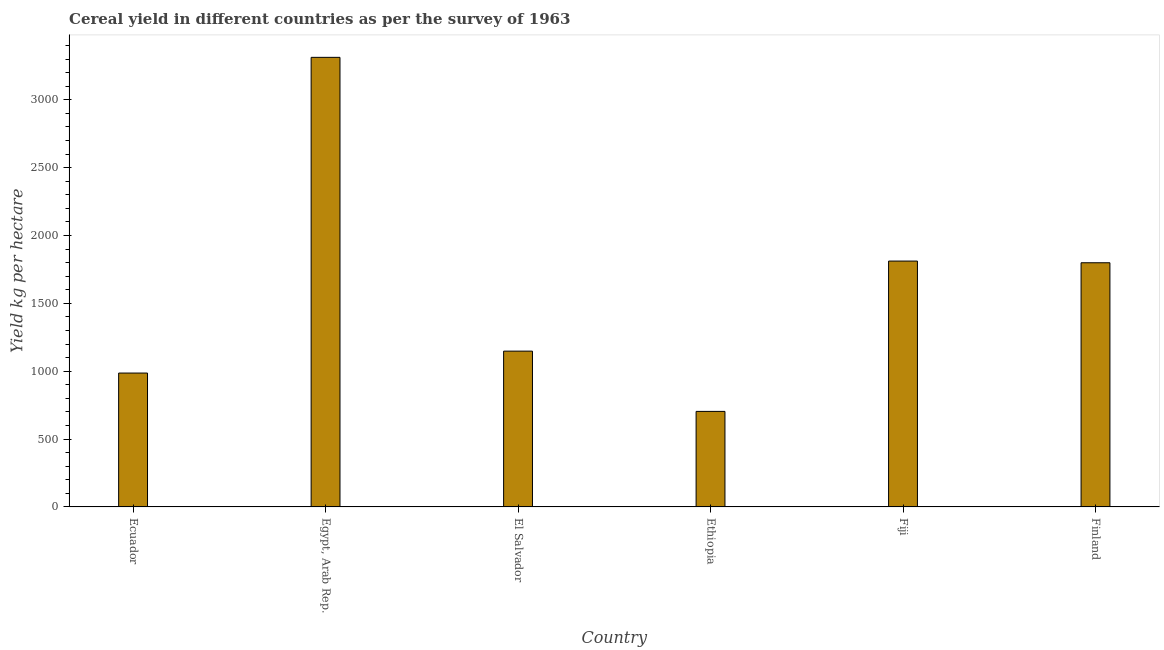Does the graph contain any zero values?
Offer a very short reply. No. Does the graph contain grids?
Your response must be concise. No. What is the title of the graph?
Your answer should be very brief. Cereal yield in different countries as per the survey of 1963. What is the label or title of the X-axis?
Provide a succinct answer. Country. What is the label or title of the Y-axis?
Keep it short and to the point. Yield kg per hectare. What is the cereal yield in El Salvador?
Your answer should be very brief. 1148.03. Across all countries, what is the maximum cereal yield?
Provide a short and direct response. 3312.81. Across all countries, what is the minimum cereal yield?
Your answer should be very brief. 703.99. In which country was the cereal yield maximum?
Your response must be concise. Egypt, Arab Rep. In which country was the cereal yield minimum?
Your answer should be very brief. Ethiopia. What is the sum of the cereal yield?
Your response must be concise. 9762.22. What is the difference between the cereal yield in Ecuador and Ethiopia?
Provide a succinct answer. 282.47. What is the average cereal yield per country?
Make the answer very short. 1627.04. What is the median cereal yield?
Provide a succinct answer. 1473.63. What is the ratio of the cereal yield in Ecuador to that in Egypt, Arab Rep.?
Your response must be concise. 0.3. Is the cereal yield in Ecuador less than that in Fiji?
Your response must be concise. Yes. Is the difference between the cereal yield in Ethiopia and Finland greater than the difference between any two countries?
Your response must be concise. No. What is the difference between the highest and the second highest cereal yield?
Offer a very short reply. 1501.1. What is the difference between the highest and the lowest cereal yield?
Give a very brief answer. 2608.82. In how many countries, is the cereal yield greater than the average cereal yield taken over all countries?
Your answer should be very brief. 3. How many bars are there?
Provide a succinct answer. 6. How many countries are there in the graph?
Give a very brief answer. 6. What is the difference between two consecutive major ticks on the Y-axis?
Your answer should be compact. 500. What is the Yield kg per hectare of Ecuador?
Keep it short and to the point. 986.46. What is the Yield kg per hectare of Egypt, Arab Rep.?
Your response must be concise. 3312.81. What is the Yield kg per hectare in El Salvador?
Offer a terse response. 1148.03. What is the Yield kg per hectare of Ethiopia?
Offer a very short reply. 703.99. What is the Yield kg per hectare of Fiji?
Offer a terse response. 1811.71. What is the Yield kg per hectare of Finland?
Your response must be concise. 1799.22. What is the difference between the Yield kg per hectare in Ecuador and Egypt, Arab Rep.?
Make the answer very short. -2326.35. What is the difference between the Yield kg per hectare in Ecuador and El Salvador?
Keep it short and to the point. -161.57. What is the difference between the Yield kg per hectare in Ecuador and Ethiopia?
Give a very brief answer. 282.47. What is the difference between the Yield kg per hectare in Ecuador and Fiji?
Your answer should be compact. -825.25. What is the difference between the Yield kg per hectare in Ecuador and Finland?
Give a very brief answer. -812.76. What is the difference between the Yield kg per hectare in Egypt, Arab Rep. and El Salvador?
Ensure brevity in your answer.  2164.78. What is the difference between the Yield kg per hectare in Egypt, Arab Rep. and Ethiopia?
Provide a succinct answer. 2608.82. What is the difference between the Yield kg per hectare in Egypt, Arab Rep. and Fiji?
Provide a short and direct response. 1501.1. What is the difference between the Yield kg per hectare in Egypt, Arab Rep. and Finland?
Your answer should be compact. 1513.58. What is the difference between the Yield kg per hectare in El Salvador and Ethiopia?
Ensure brevity in your answer.  444.04. What is the difference between the Yield kg per hectare in El Salvador and Fiji?
Your response must be concise. -663.68. What is the difference between the Yield kg per hectare in El Salvador and Finland?
Give a very brief answer. -651.2. What is the difference between the Yield kg per hectare in Ethiopia and Fiji?
Offer a very short reply. -1107.72. What is the difference between the Yield kg per hectare in Ethiopia and Finland?
Give a very brief answer. -1095.23. What is the difference between the Yield kg per hectare in Fiji and Finland?
Your answer should be very brief. 12.49. What is the ratio of the Yield kg per hectare in Ecuador to that in Egypt, Arab Rep.?
Make the answer very short. 0.3. What is the ratio of the Yield kg per hectare in Ecuador to that in El Salvador?
Provide a short and direct response. 0.86. What is the ratio of the Yield kg per hectare in Ecuador to that in Ethiopia?
Your answer should be very brief. 1.4. What is the ratio of the Yield kg per hectare in Ecuador to that in Fiji?
Keep it short and to the point. 0.54. What is the ratio of the Yield kg per hectare in Ecuador to that in Finland?
Provide a succinct answer. 0.55. What is the ratio of the Yield kg per hectare in Egypt, Arab Rep. to that in El Salvador?
Offer a very short reply. 2.89. What is the ratio of the Yield kg per hectare in Egypt, Arab Rep. to that in Ethiopia?
Ensure brevity in your answer.  4.71. What is the ratio of the Yield kg per hectare in Egypt, Arab Rep. to that in Fiji?
Make the answer very short. 1.83. What is the ratio of the Yield kg per hectare in Egypt, Arab Rep. to that in Finland?
Ensure brevity in your answer.  1.84. What is the ratio of the Yield kg per hectare in El Salvador to that in Ethiopia?
Your response must be concise. 1.63. What is the ratio of the Yield kg per hectare in El Salvador to that in Fiji?
Your answer should be compact. 0.63. What is the ratio of the Yield kg per hectare in El Salvador to that in Finland?
Give a very brief answer. 0.64. What is the ratio of the Yield kg per hectare in Ethiopia to that in Fiji?
Offer a terse response. 0.39. What is the ratio of the Yield kg per hectare in Ethiopia to that in Finland?
Your answer should be compact. 0.39. 